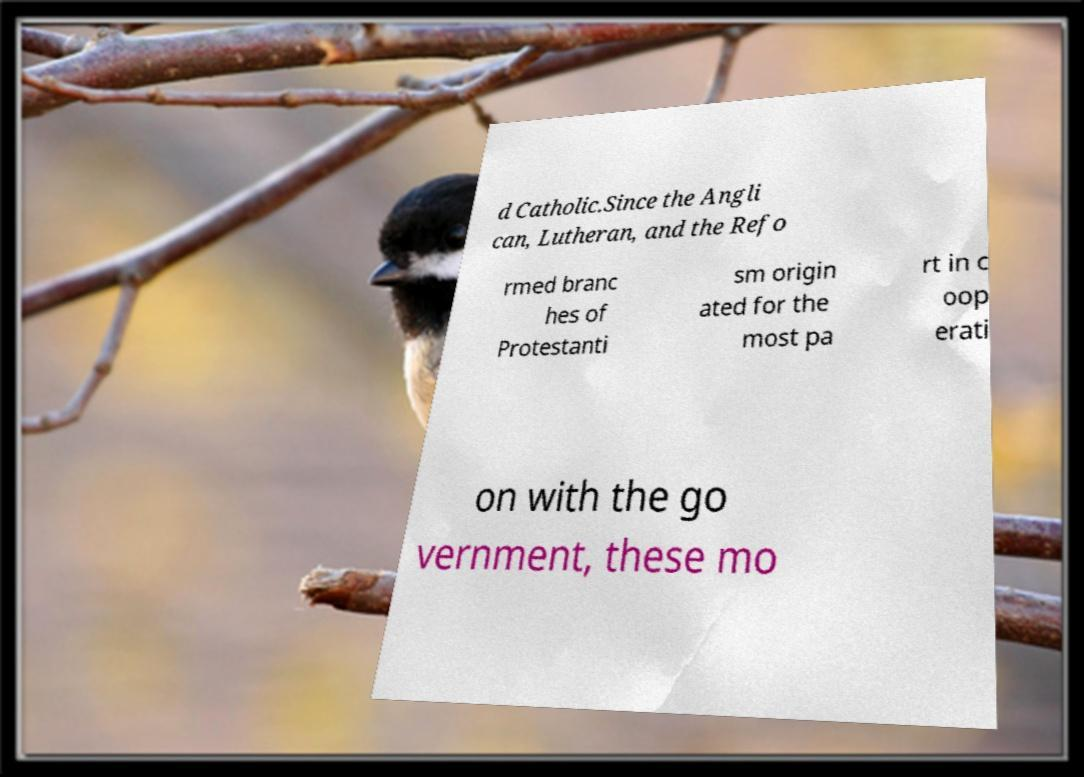Can you read and provide the text displayed in the image?This photo seems to have some interesting text. Can you extract and type it out for me? d Catholic.Since the Angli can, Lutheran, and the Refo rmed branc hes of Protestanti sm origin ated for the most pa rt in c oop erati on with the go vernment, these mo 